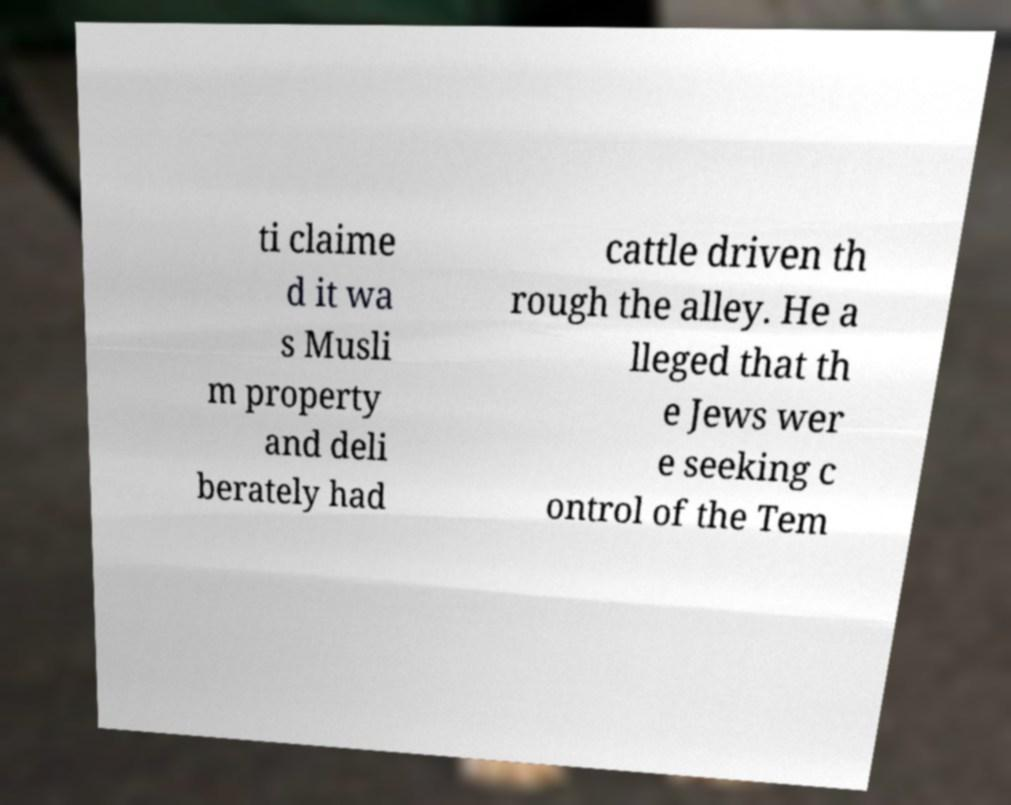I need the written content from this picture converted into text. Can you do that? ti claime d it wa s Musli m property and deli berately had cattle driven th rough the alley. He a lleged that th e Jews wer e seeking c ontrol of the Tem 